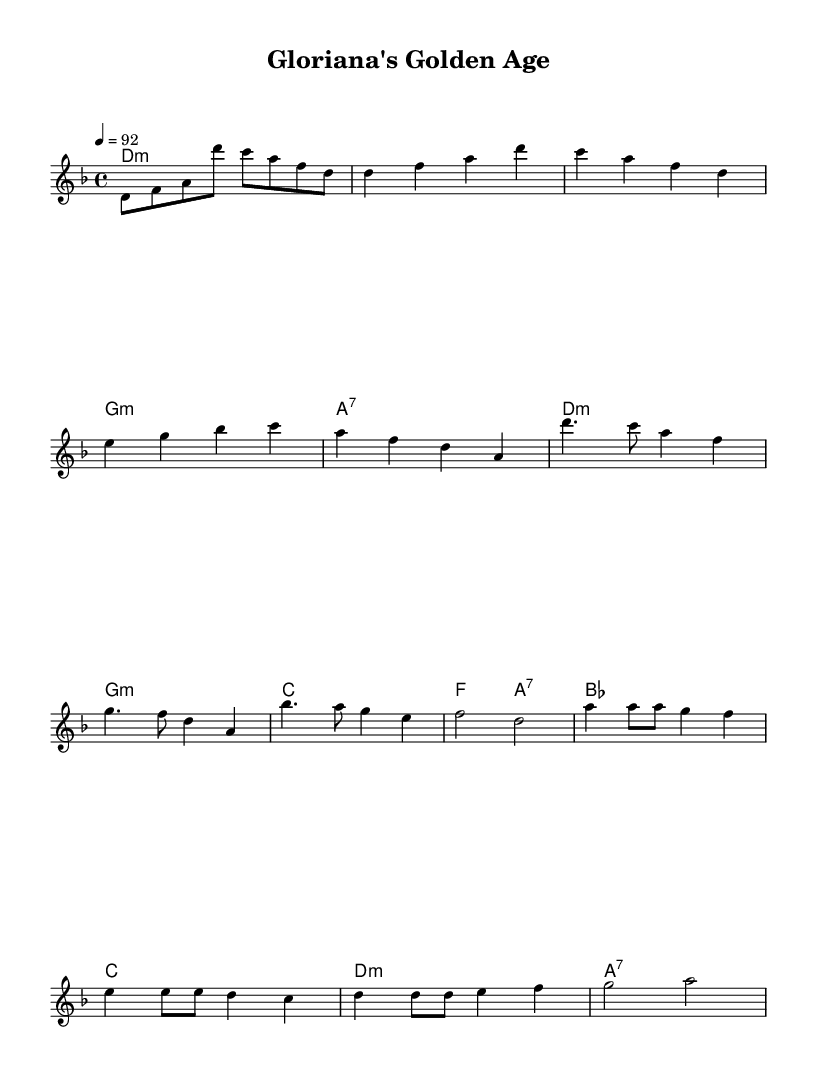What is the key signature of this music? The key signature is indicated by the key signature symbol at the beginning of the staff. In this case, it shows D minor, which has one flat (B flat).
Answer: D minor What is the time signature of this music? The time signature is found at the beginning of the score. In this sheet music, it is indicated as 4/4, meaning there are four beats per measure and the quarter note receives one beat.
Answer: 4/4 What is the tempo marking for this piece? The tempo marking is usually provided at the beginning of the piece, indicating the speed. Here, it is marked as "4 = 92," which means there are 92 beats per minute.
Answer: 92 How many measures are in the chorus? By counting the measures in the chorus section, which is the repeated portion following each verse, it can be determined that there are four measures in this section.
Answer: 4 What chord follows the D minor in the verse? The chords are listed in the harmonies section under the verse. After the D minor chord, there is another D minor chord which follows immediately in the subsequent measure.
Answer: D minor What is the structure of this rap indicated by the labels? The structure of the piece is labeled with distinct names: "Intro," "Verse," "Chorus," and "Bridge." Each section corresponds to different rhythms and melodies typical in rap.
Answer: Intro, Verse, Chorus, Bridge 